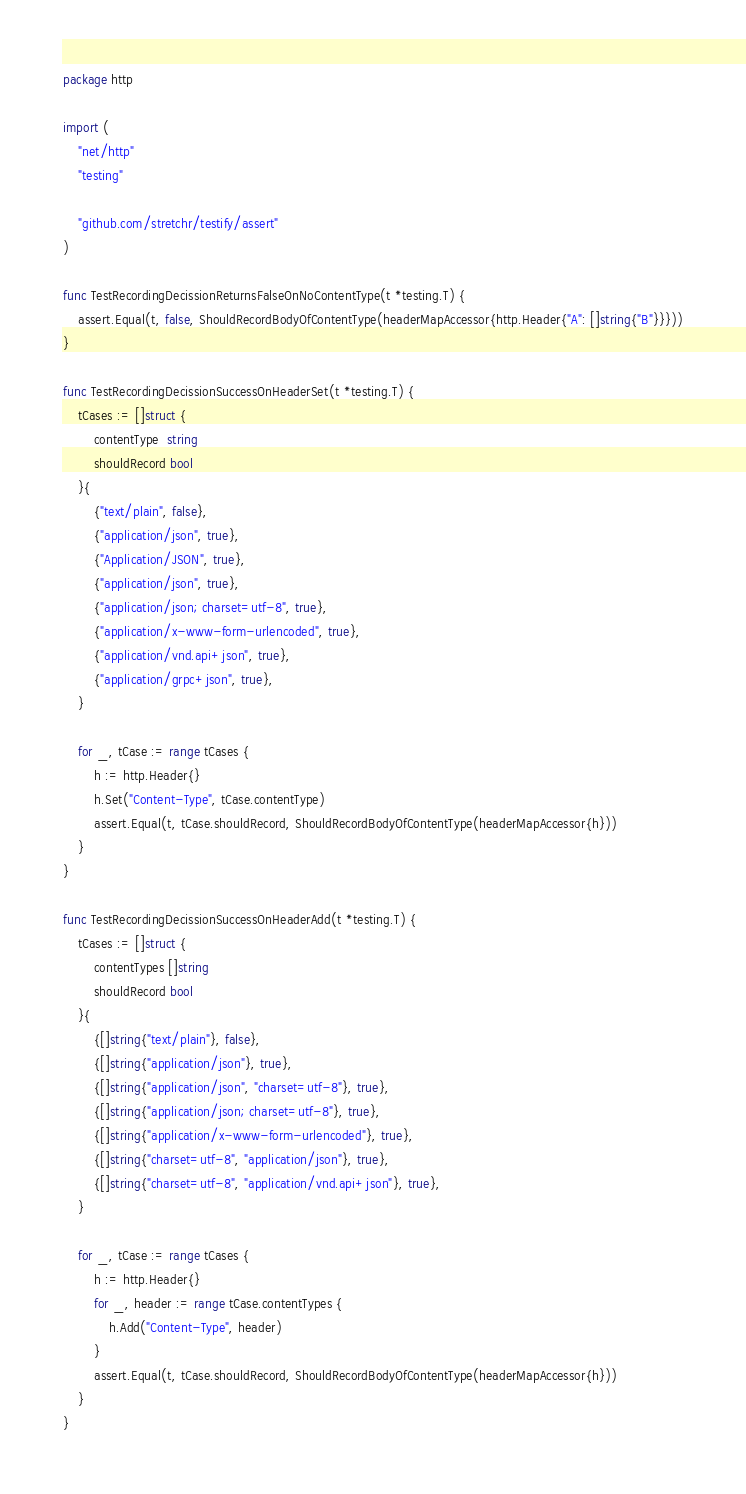<code> <loc_0><loc_0><loc_500><loc_500><_Go_>package http

import (
	"net/http"
	"testing"

	"github.com/stretchr/testify/assert"
)

func TestRecordingDecissionReturnsFalseOnNoContentType(t *testing.T) {
	assert.Equal(t, false, ShouldRecordBodyOfContentType(headerMapAccessor{http.Header{"A": []string{"B"}}}))
}

func TestRecordingDecissionSuccessOnHeaderSet(t *testing.T) {
	tCases := []struct {
		contentType  string
		shouldRecord bool
	}{
		{"text/plain", false},
		{"application/json", true},
		{"Application/JSON", true},
		{"application/json", true},
		{"application/json; charset=utf-8", true},
		{"application/x-www-form-urlencoded", true},
		{"application/vnd.api+json", true},
		{"application/grpc+json", true},
	}

	for _, tCase := range tCases {
		h := http.Header{}
		h.Set("Content-Type", tCase.contentType)
		assert.Equal(t, tCase.shouldRecord, ShouldRecordBodyOfContentType(headerMapAccessor{h}))
	}
}

func TestRecordingDecissionSuccessOnHeaderAdd(t *testing.T) {
	tCases := []struct {
		contentTypes []string
		shouldRecord bool
	}{
		{[]string{"text/plain"}, false},
		{[]string{"application/json"}, true},
		{[]string{"application/json", "charset=utf-8"}, true},
		{[]string{"application/json; charset=utf-8"}, true},
		{[]string{"application/x-www-form-urlencoded"}, true},
		{[]string{"charset=utf-8", "application/json"}, true},
		{[]string{"charset=utf-8", "application/vnd.api+json"}, true},
	}

	for _, tCase := range tCases {
		h := http.Header{}
		for _, header := range tCase.contentTypes {
			h.Add("Content-Type", header)
		}
		assert.Equal(t, tCase.shouldRecord, ShouldRecordBodyOfContentType(headerMapAccessor{h}))
	}
}
</code> 